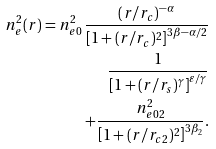Convert formula to latex. <formula><loc_0><loc_0><loc_500><loc_500>n _ { e } ^ { 2 } ( r ) = n _ { e 0 } ^ { 2 } \, \frac { ( r / r _ { c } ) ^ { - \alpha } } { \left [ 1 + ( r / r _ { c } ) ^ { 2 } \right ] ^ { 3 \beta - \alpha / 2 } } \\ \frac { 1 } { \left [ 1 + ( r / r _ { s } ) ^ { \gamma } \right ] ^ { \varepsilon / \gamma } } \\ + \frac { n _ { e 0 2 } ^ { 2 } } { \left [ 1 + ( r / r _ { c 2 } ) ^ { 2 } \right ] ^ { 3 \beta _ { 2 } } } .</formula> 